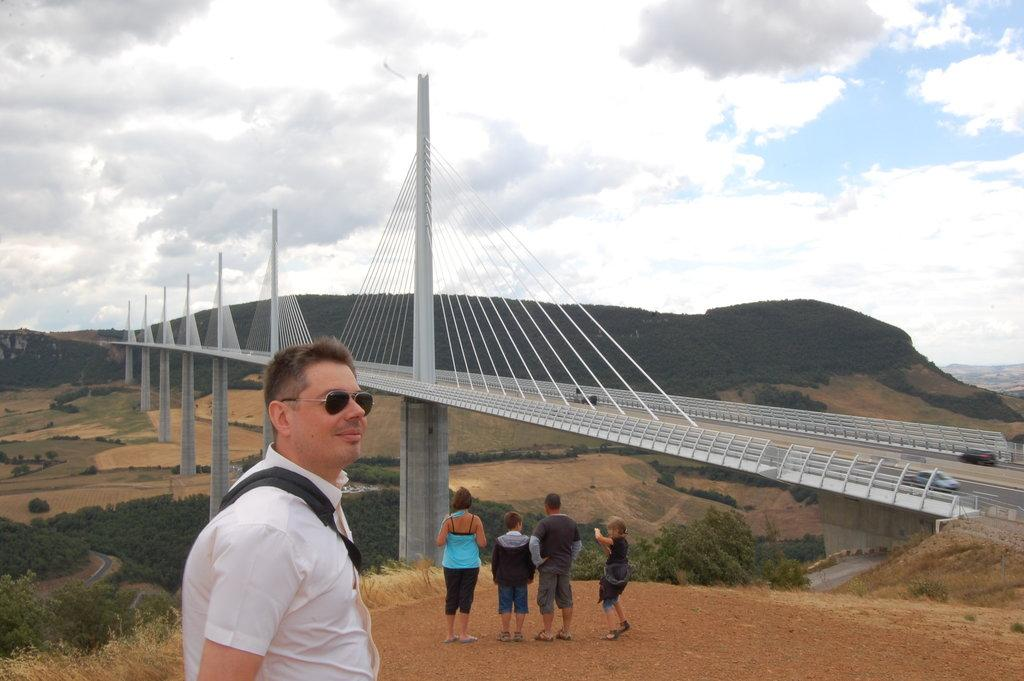What are the people in the image doing? The persons in the image are standing on the ground. Can you describe the clothing of one of the persons? One person is wearing a bag. What type of structure can be seen in the image? There is a bridge in the image. What natural features are present in the image? There are mountains, trees, and plants in the image. What part of the natural environment is visible in the image? The sky is visible in the image. What type of carriage can be seen being pulled by horses in the image? There is no carriage or horses present in the image. How can the persons in the image be helped to cross the bridge? The persons in the image do not appear to need help crossing the bridge, as they are already standing on the ground. 